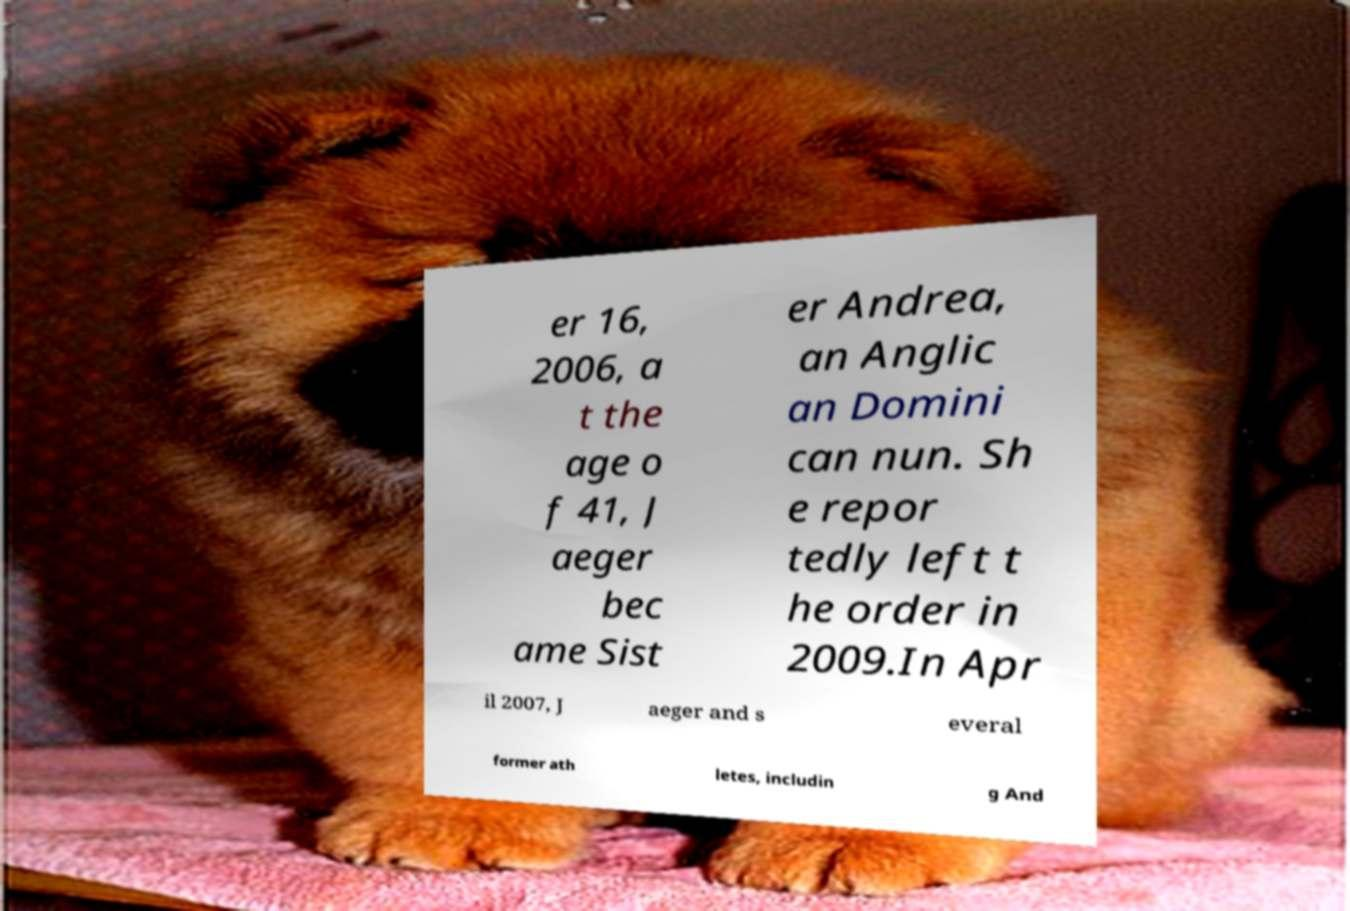Please read and relay the text visible in this image. What does it say? er 16, 2006, a t the age o f 41, J aeger bec ame Sist er Andrea, an Anglic an Domini can nun. Sh e repor tedly left t he order in 2009.In Apr il 2007, J aeger and s everal former ath letes, includin g And 